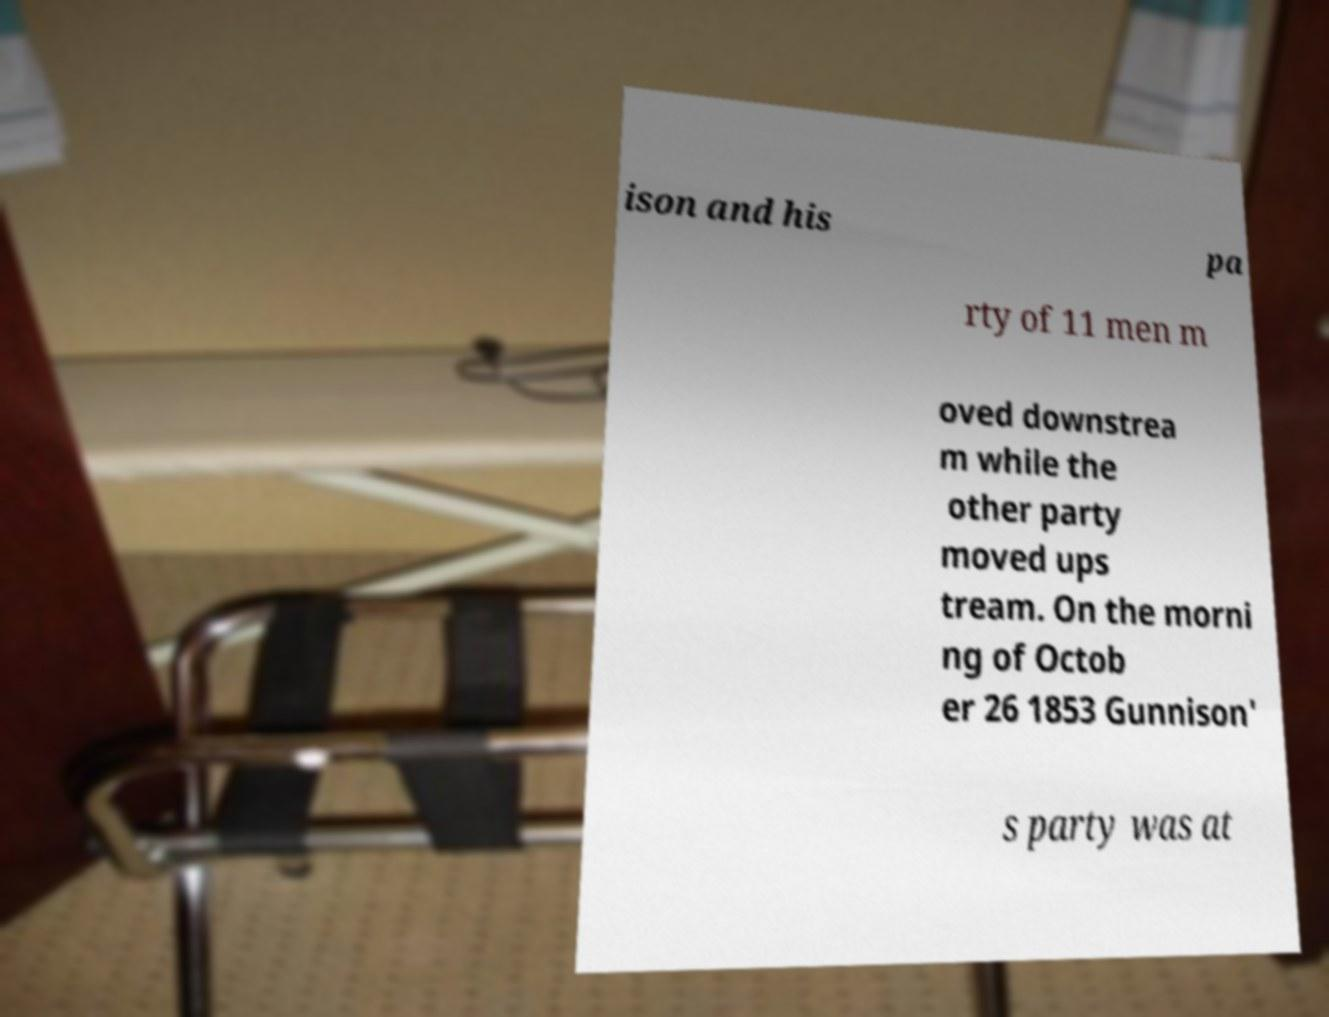Could you assist in decoding the text presented in this image and type it out clearly? ison and his pa rty of 11 men m oved downstrea m while the other party moved ups tream. On the morni ng of Octob er 26 1853 Gunnison' s party was at 